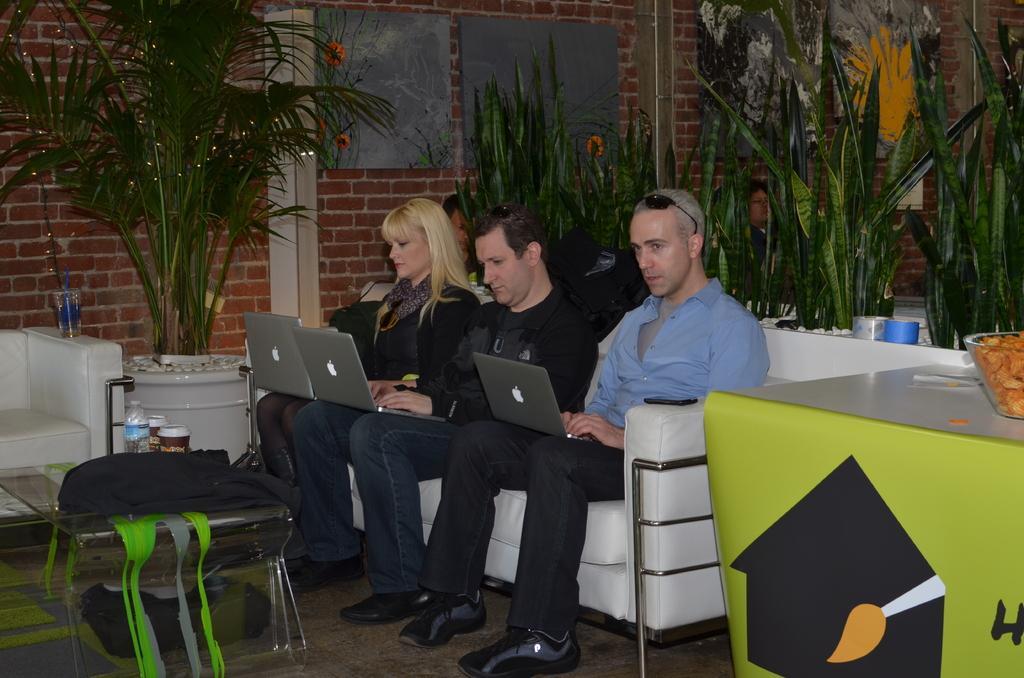How would you summarize this image in a sentence or two? This picture is clicked inside the room. In the middle of the picture, we see a white soap on which three people are sitting on it. The man in the middle of the sofa, wearing black jacket and blue jeans is holding laptop in his hands and he is operating it. To the left of him, we see a man in blue shirt is also operating laptop. On the left corner of the sofa, we see woman in black dress is holding laptop in her hands and she is also operating it and on sofa we see a mobile phone. Beside that, we see a green table on which bowl is placed. Beside that, we see plants. Behind that, we see a building which is made up of red color bricks. On the left bottom of the picture, we see a glass table on which black color bag is placed on it. 